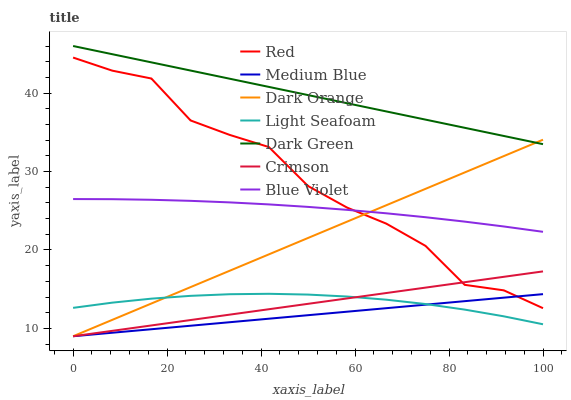Does Medium Blue have the minimum area under the curve?
Answer yes or no. Yes. Does Dark Green have the maximum area under the curve?
Answer yes or no. Yes. Does Blue Violet have the minimum area under the curve?
Answer yes or no. No. Does Blue Violet have the maximum area under the curve?
Answer yes or no. No. Is Medium Blue the smoothest?
Answer yes or no. Yes. Is Red the roughest?
Answer yes or no. Yes. Is Blue Violet the smoothest?
Answer yes or no. No. Is Blue Violet the roughest?
Answer yes or no. No. Does Blue Violet have the lowest value?
Answer yes or no. No. Does Blue Violet have the highest value?
Answer yes or no. No. Is Light Seafoam less than Dark Green?
Answer yes or no. Yes. Is Blue Violet greater than Light Seafoam?
Answer yes or no. Yes. Does Light Seafoam intersect Dark Green?
Answer yes or no. No. 